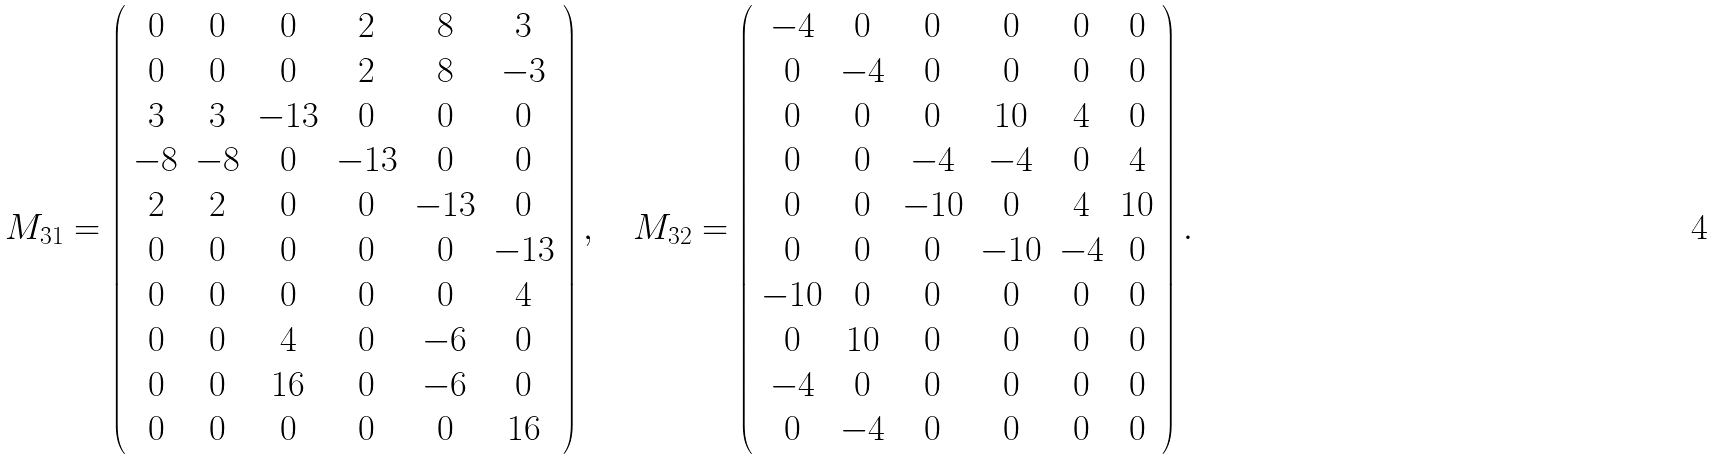<formula> <loc_0><loc_0><loc_500><loc_500>M _ { 3 1 } = \left ( \begin{array} { c c c c c c } 0 & 0 & 0 & 2 & 8 & 3 \\ 0 & 0 & 0 & 2 & 8 & - 3 \\ 3 & 3 & - 1 3 & 0 & 0 & 0 \\ - 8 & - 8 & 0 & - 1 3 & 0 & 0 \\ 2 & 2 & 0 & 0 & - 1 3 & 0 \\ 0 & 0 & 0 & 0 & 0 & - 1 3 \\ 0 & 0 & 0 & 0 & 0 & 4 \\ 0 & 0 & 4 & 0 & - 6 & 0 \\ 0 & 0 & 1 6 & 0 & - 6 & 0 \\ 0 & 0 & 0 & 0 & 0 & 1 6 \\ \end{array} \right ) , \quad M _ { 3 2 } = \left ( \begin{array} { c c c c c c } - 4 & 0 & 0 & 0 & 0 & 0 \\ 0 & - 4 & 0 & 0 & 0 & 0 \\ 0 & 0 & 0 & 1 0 & 4 & 0 \\ 0 & 0 & - 4 & - 4 & 0 & 4 \\ 0 & 0 & - 1 0 & 0 & 4 & 1 0 \\ 0 & 0 & 0 & - 1 0 & - 4 & 0 \\ - 1 0 & 0 & 0 & 0 & 0 & 0 \\ 0 & 1 0 & 0 & 0 & 0 & 0 \\ - 4 & 0 & 0 & 0 & 0 & 0 \\ 0 & - 4 & 0 & 0 & 0 & 0 \\ \end{array} \right ) .</formula> 